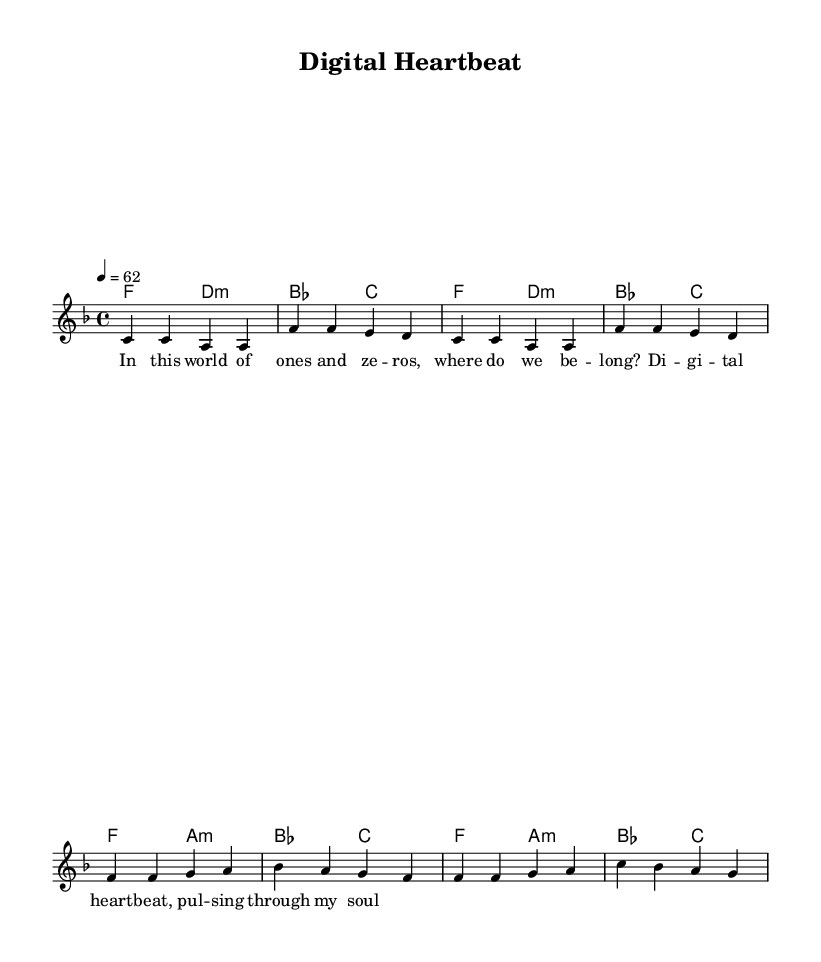What is the key signature of this music? The key signature is F major, which has one flat (B flat). This can be determined by looking at the key signature at the beginning of the staff, where one flat (B) is indicated.
Answer: F major What is the time signature of this music? The time signature is 4/4, which is seen in the time signature marking at the beginning of the score. This indicates that there are four beats in each measure and that each quarter note gets one beat.
Answer: 4/4 What is the tempo marking of this piece? The tempo marking is 62 beats per minute, stated above the staff as "4 = 62". This indicates how fast the piece should be played, with the quarter note (the '4') getting 62 beats per minute.
Answer: 62 How many measures are in the piece? There are eight measures in total, as we can count the individual groupings of notes and rests separated by bar lines throughout the sheet music.
Answer: 8 What is the chord progression in the verse? The chord progression in the verse alternates between F major and D minor, as indicated by the harmonies below the melody line. This shows that the chords change in a specific pattern to support the melody structure.
Answer: F major, D minor What lyrical theme is reflected in the chorus? The lyrical theme in the chorus revolves around digital connectivity and emotional expression, suggesting a relationship between technology and personal feelings. This can be inferred from the words "Digital heartbeat, pulsing through my soul," indicating a blend of technology with human emotion.
Answer: Digital connectivity What type of genre does this piece fit into? The piece fits into the Soul genre, as indicated by its smooth ballad style, emotional depth, and focus on themes of personal experience and technology's impact on human connections. These characteristics align with the stylistic elements typical of Soul music.
Answer: Soul 